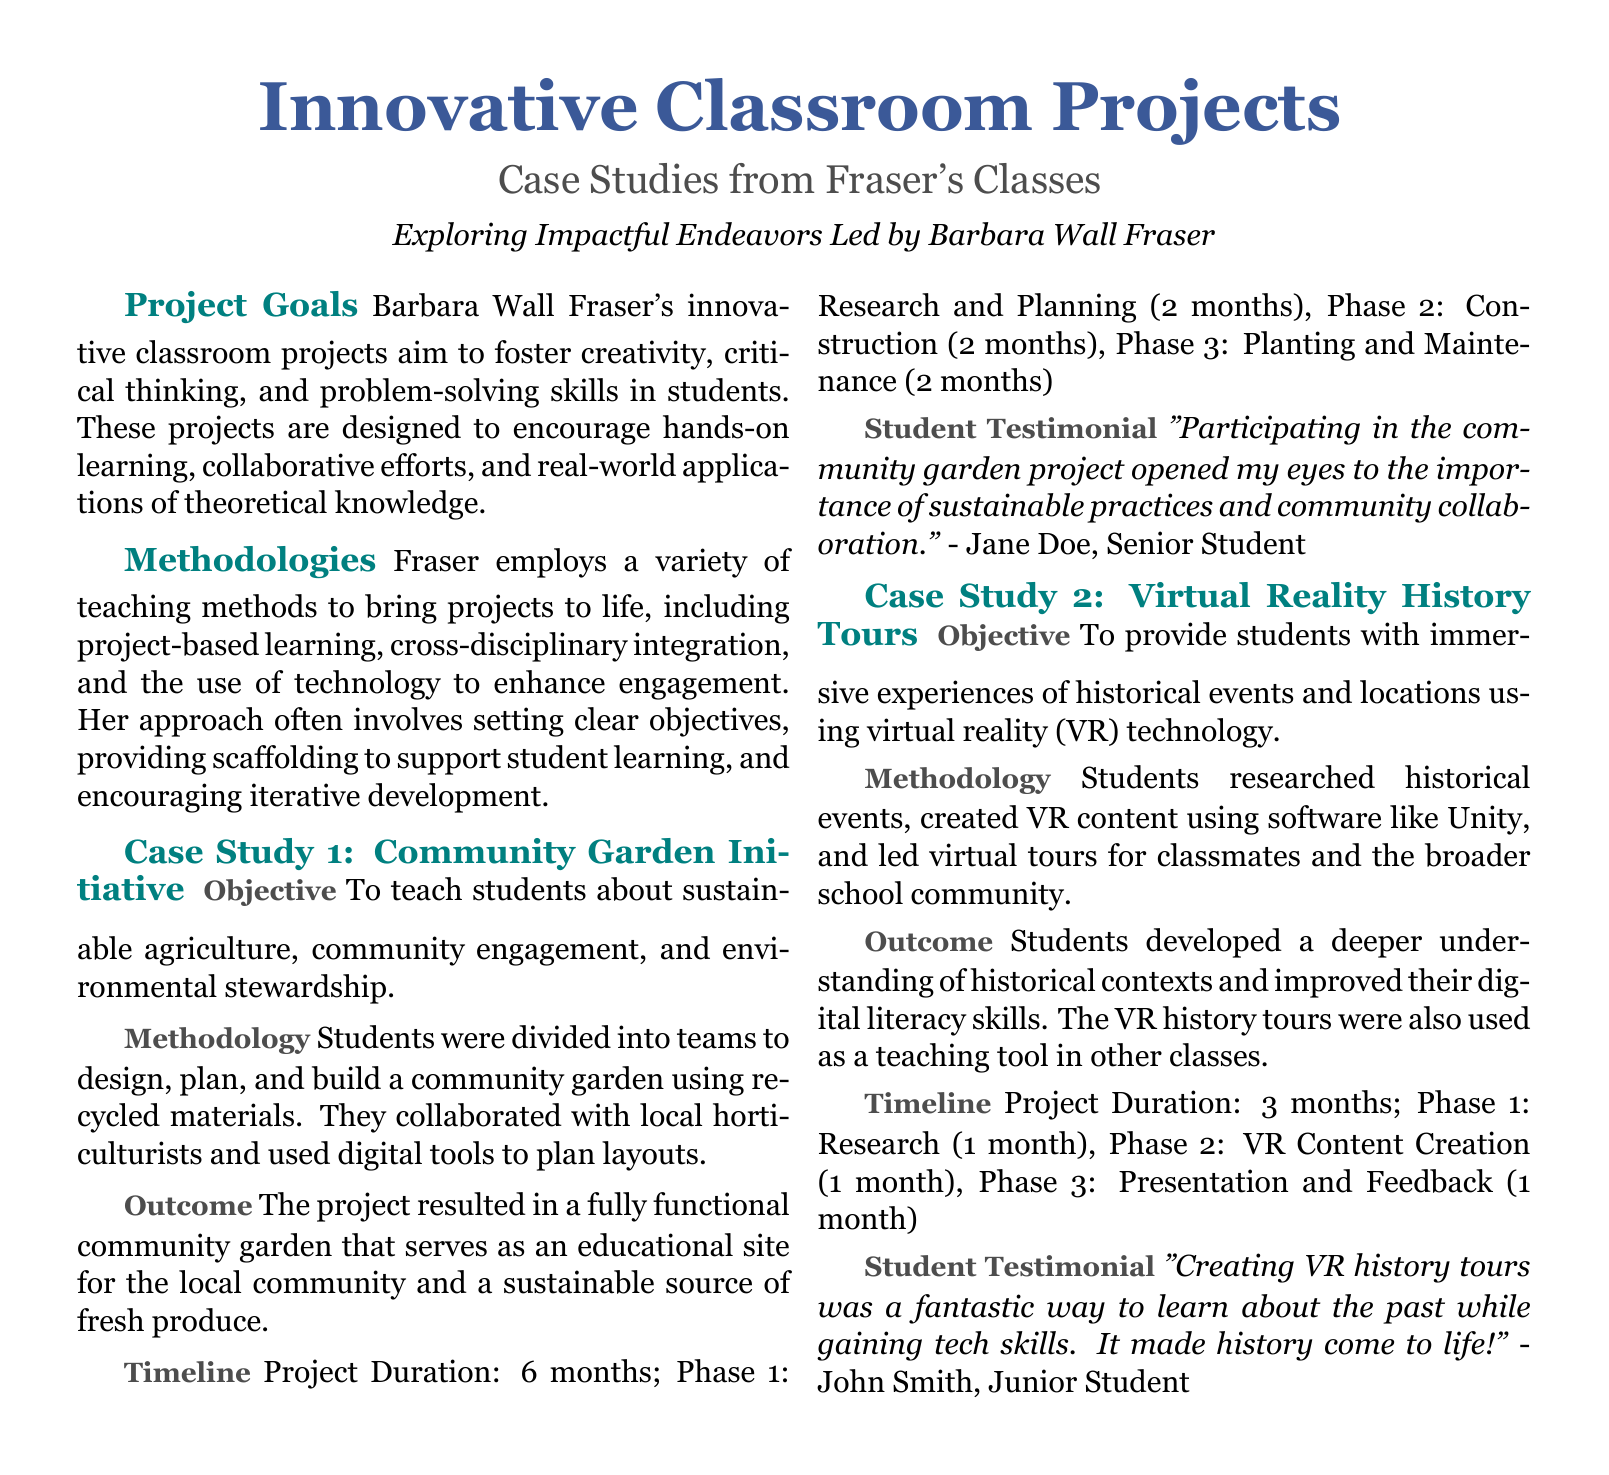What is the main objective of Barbara Wall Fraser's projects? The main objective is to foster creativity, critical thinking, and problem-solving skills in students.
Answer: Creativity, critical thinking, and problem-solving skills What technology did students use for the Virtual Reality History Tours project? Students used software like Unity to create VR content for the project.
Answer: Unity How long did the Community Garden Initiative last? The project duration is specified as 6 months.
Answer: 6 months What was the outcome of the Community Garden Initiative? The outcome was a fully functional community garden that serves as an educational site for the local community.
Answer: Fully functional community garden How many phases were there in the Virtual Reality History Tours project? The project consists of 3 phases: Research, VR Content Creation, and Presentation and Feedback.
Answer: 3 phases How did students collaborate in the Community Garden Initiative? Students collaborated in teams to design, plan, and build the garden using recycled materials.
Answer: In teams What kind of learning approach does Fraser emphasize in her projects? Fraser emphasizes a project-based learning approach in her methodologies.
Answer: Project-based learning What did John Smith say about creating VR history tours? John Smith stated that it was a fantastic way to learn about the past while gaining tech skills.
Answer: A fantastic way to learn about the past 